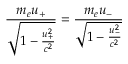Convert formula to latex. <formula><loc_0><loc_0><loc_500><loc_500>\frac { m _ { e } u _ { + } } { \sqrt { 1 - \frac { u _ { + } ^ { 2 } } { c ^ { 2 } } } } = \frac { m _ { e } u _ { - } } { \sqrt { 1 - \frac { u _ { - } ^ { 2 } } { c ^ { 2 } } } }</formula> 